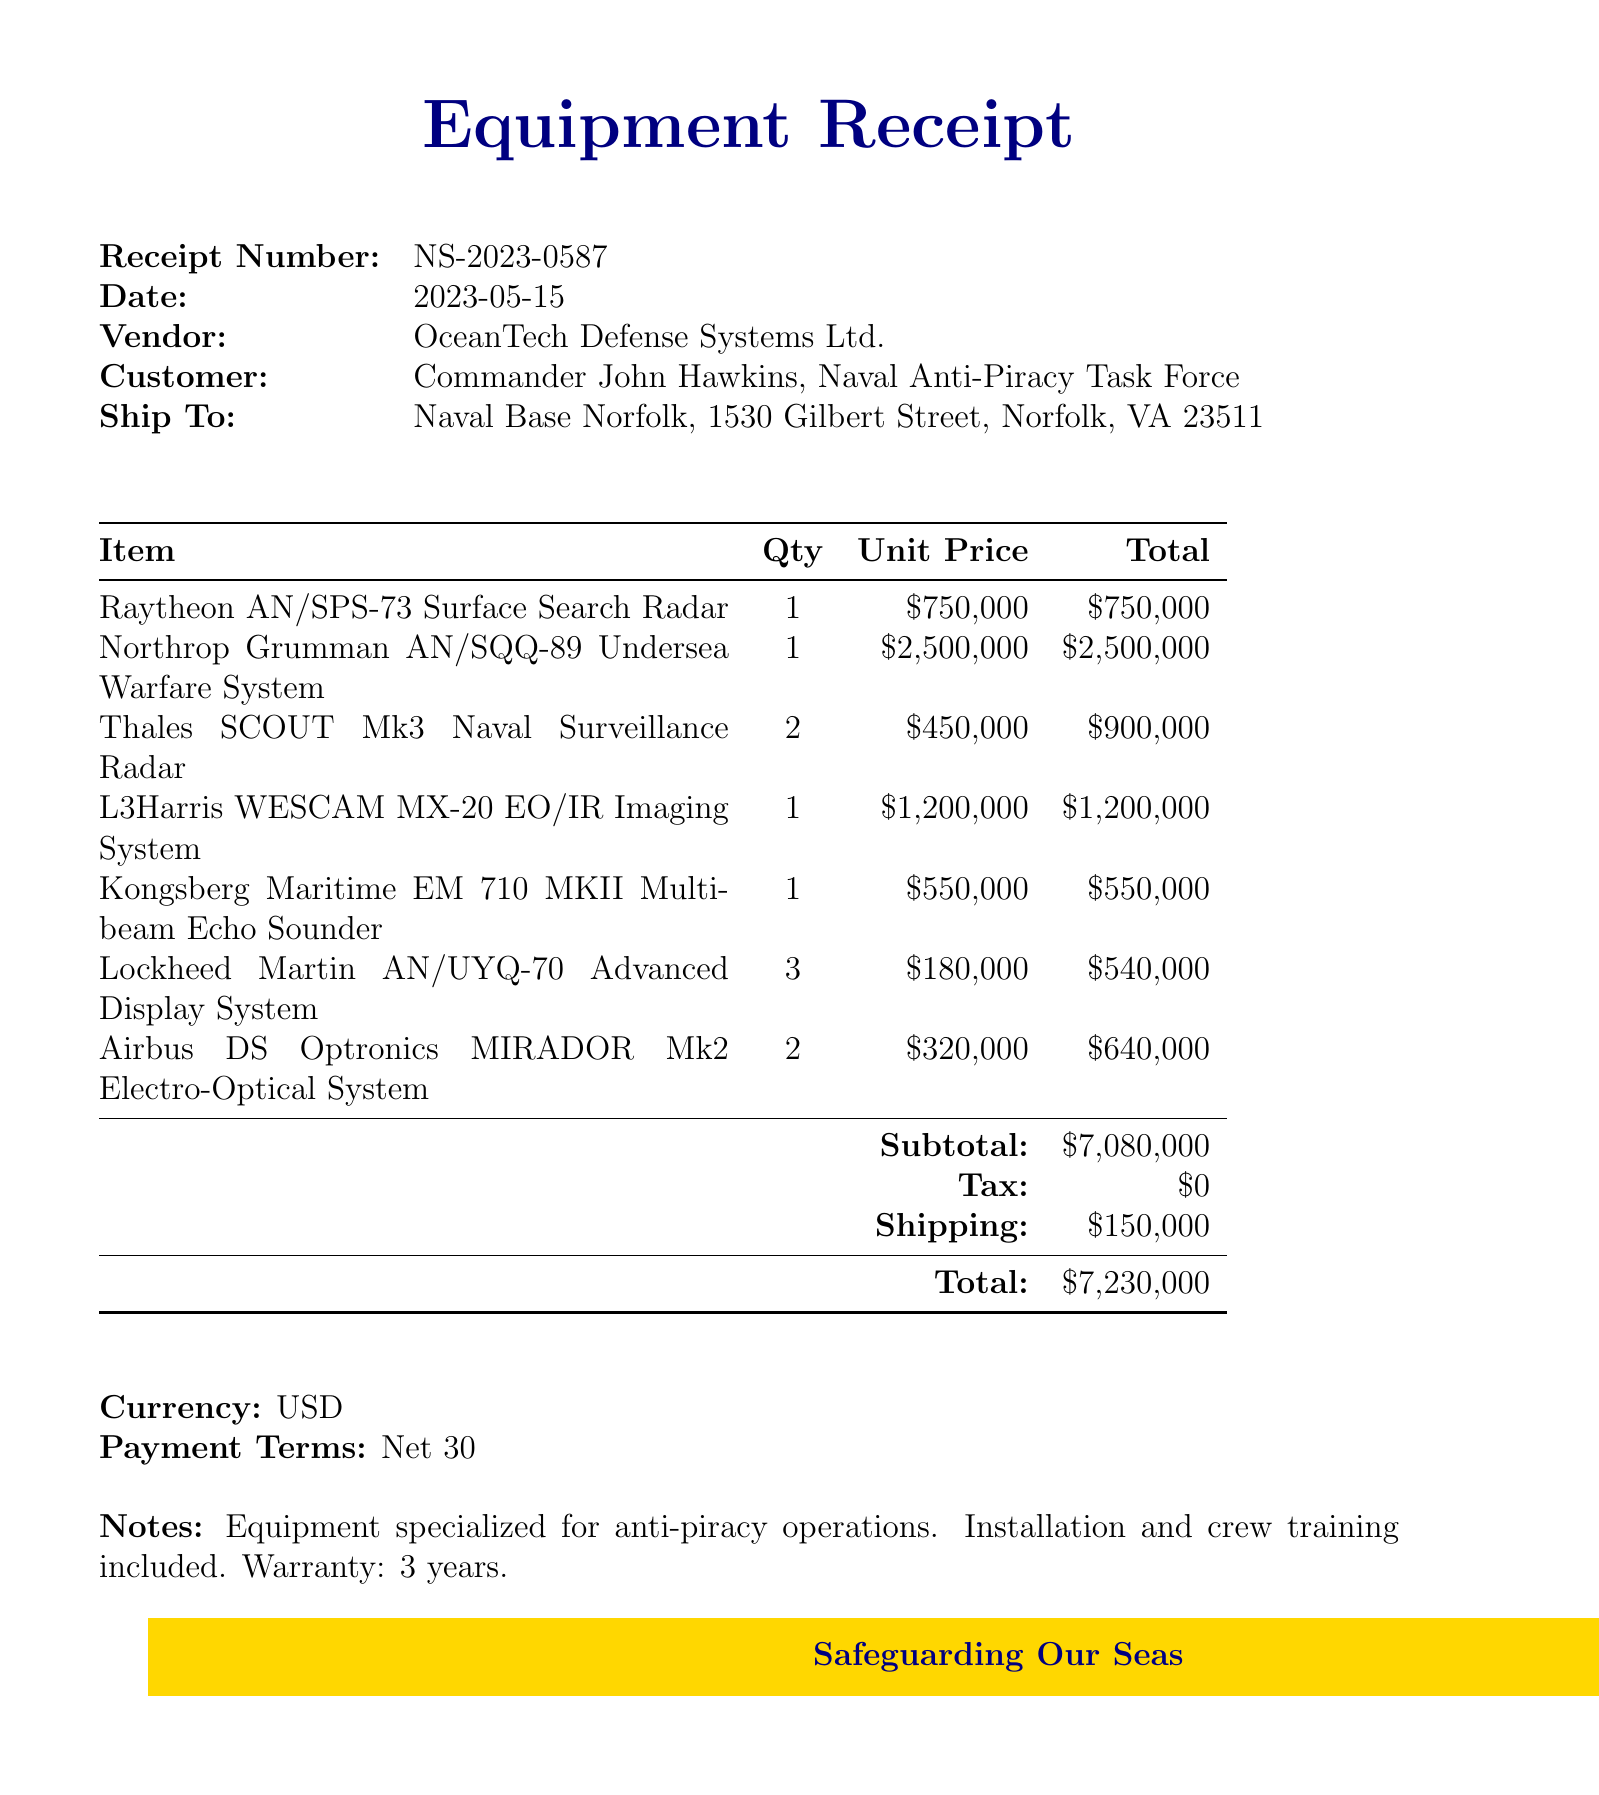What is the receipt number? The receipt number is a unique identifier for the transaction, which is provided in the document.
Answer: NS-2023-0587 Who is the vendor? The vendor is the company that sold the equipment, which is noted in the document.
Answer: OceanTech Defense Systems Ltd What is the date of the receipt? The date indicates when the transaction took place; it is specified in the document.
Answer: 2023-05-15 What is the subtotal of the purchase? The subtotal refers to the total amount before tax and shipping, which is detailed in the document.
Answer: $7,080,000 How many Kongsberg Maritime EM 710 MKII Multibeam Echo Sounders were ordered? This question refers to the quantity of a specific item listed in the document.
Answer: 1 What is the total amount due? The total amount includes subtotal, any applicable taxes, and shipping costs, summarized in the document.
Answer: $7,230,000 What are the payment terms? Payment terms specify the time frame for payment, which is included in the document.
Answer: Net 30 What type of equipment is specified for the purchase? This question looks for the purpose of the equipment, which is outlined in the document details.
Answer: Anti-piracy operations How many Lockheed Martin AN/UYQ-70 Advanced Display Systems were included in the order? This question asks about the quantity of a specific item listed in the document.
Answer: 3 